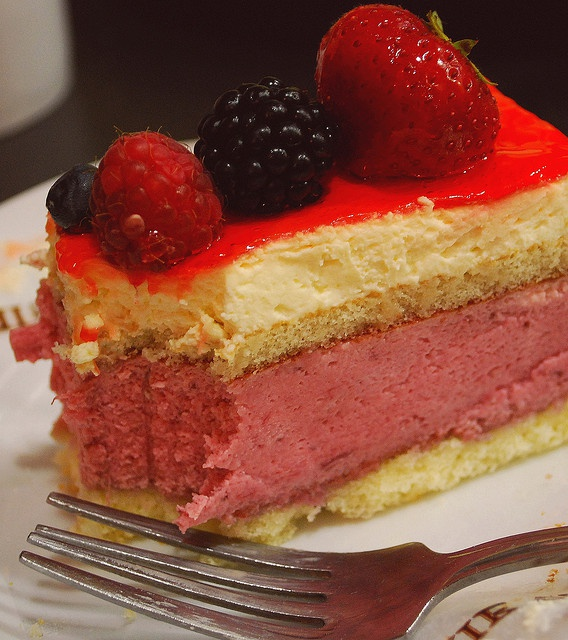Describe the objects in this image and their specific colors. I can see cake in gray, brown, and maroon tones and fork in gray and maroon tones in this image. 